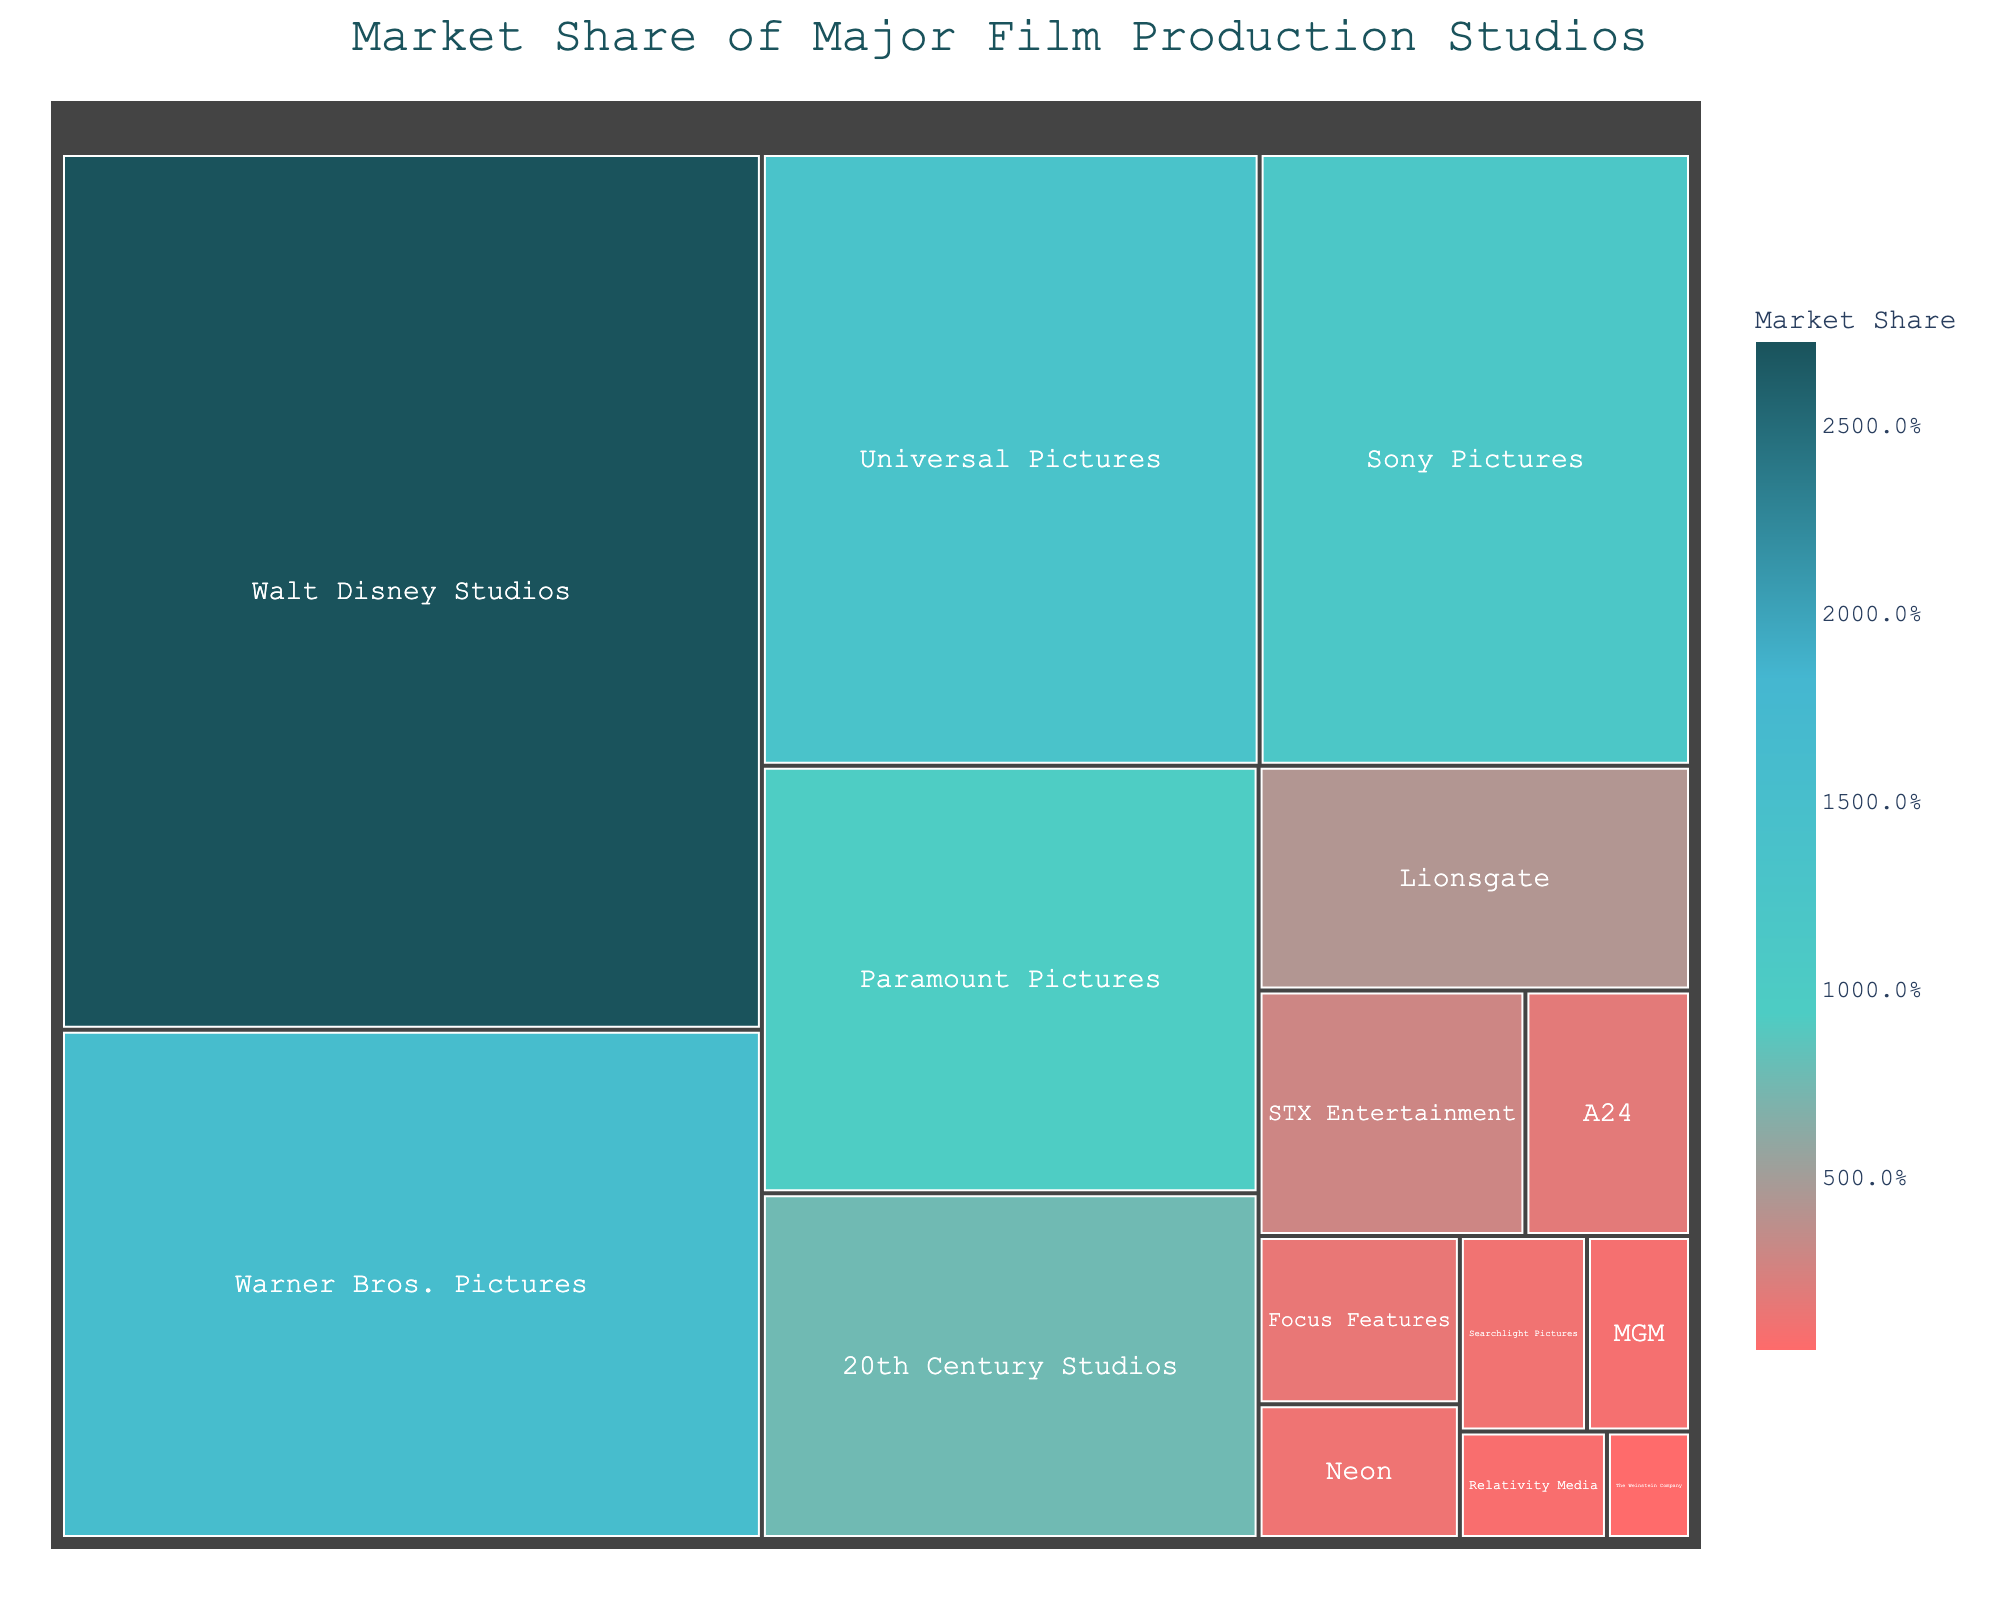what is the market share of the biggest studio, Walt Disney Studios? The title of the figure is "Market Share of Major Film Production Studios." We locate Walt Disney Studios in the treemap and see that it has the largest block with a label showing a 27.2% market share.
Answer: 27.2% Which studio has the smallest market share and what is it? By looking at the smallest block in the treemap, we find it belongs to The Weinstein Company, and its label shows a market share of 0.4%.
Answer: The Weinstein Company, 0.4% How does the market share of Warner Bros. Pictures compare to Universal Pictures? Examining the blocks for Warner Bros. Pictures and Universal Pictures, we see they have market shares of 15.8% and 13.5%, respectively. This indicates that Warner Bros. Pictures has a slightly higher market share.
Answer: Warner Bros. Pictures has higher market share What is the combined market share of 20th Century Studios and Lionsgate? Identify the blocks for 20th Century Studios and Lionsgate in the treemap. The market share for 20th Century Studios is 7.6% and for Lionsgate is 4.3%. Adding them together, 7.6 + 4.3 equals 11.9.
Answer: 11.9% List all studios with a market share higher than 10%. By looking at the labels in the treemap, the studios with a market share higher than 10% are: Walt Disney Studios (27.2%), Warner Bros. Pictures (15.8%), Universal Pictures (13.5%), and Sony Pictures (11.7%).
Answer: Walt Disney Studios, Warner Bros. Pictures, Universal Pictures, Sony Pictures How does the market share of Sony Pictures compare to Paramount Pictures? Locate Sony Pictures and Paramount Pictures in the treemap. Sony Pictures has a market share of 11.7%, while Paramount Pictures has a market share of 9.4%. This shows that Sony Pictures has a higher market share.
Answer: Sony Pictures has higher market share What is the total market share of all studios with less than 2% shares? Identify the studios with less than 2% market share in the treemap: A24 (1.8%), Focus Features (1.5%), Neon (1.2%), Searchlight Pictures (1.1%), MGM (0.9%), Relativity Media (0.7%), and The Weinstein Company (0.4%). Adding them up, 1.8 + 1.5 + 1.2 + 1.1 + 0.9 + 0.7 + 0.4 equals 7.6.
Answer: 7.6% Which studio has a market share closest to 5%? In the treemap, we look for the studio whose market share is nearest to 5%. Lionsgate has a market share of 4.3%, which is closest to 5%.
Answer: Lionsgate What are the relative sizes of the blocks for STX Entertainment and Focus Features? Locate the blocks for STX Entertainment and Focus Features in the figure. STX Entertainment has a market share of 2.9%, and Focus Features has 1.5%. Thus, the block for STX Entertainment is almost twice as large as that for Focus Features.
Answer: STX Entertainment is almost twice Focus Features How much more market share does Walt Disney Studios have compared to all studios with less than 2% shares combined? Walt Disney Studios has a market share of 27.2%. The total market share of studios with less than 2% shares is 7.6% (as calculated earlier). The difference is 27.2 - 7.6, which equals 19.6.
Answer: 19.6% 